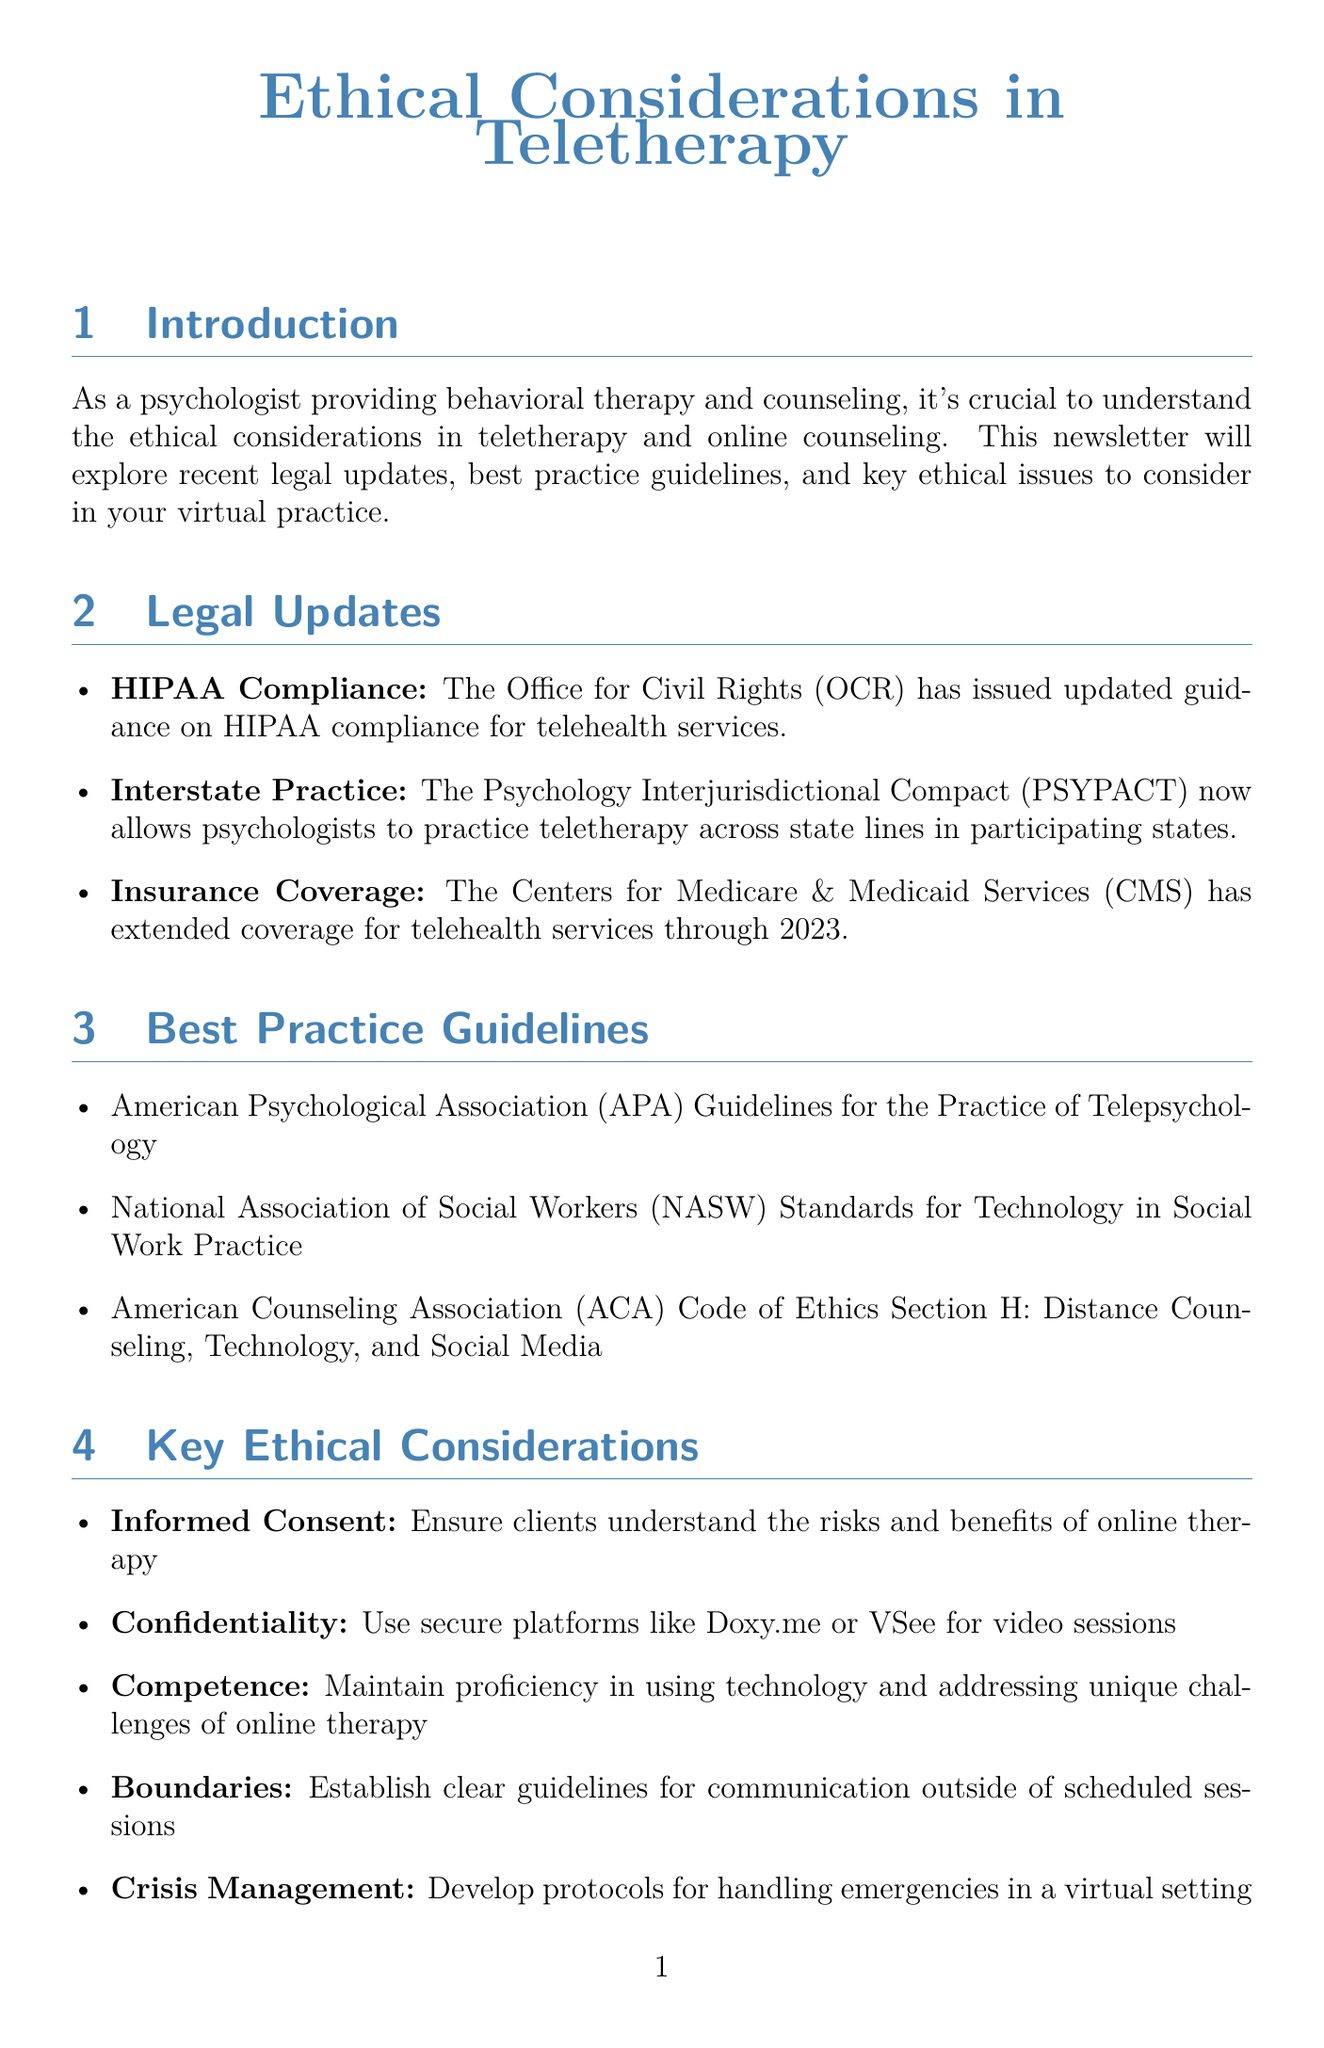What is the title of the newsletter? The title is explicitly stated at the beginning of the document, which is "Ethical Considerations in Teletherapy."
Answer: Ethical Considerations in Teletherapy Who issued updated guidance on HIPAA compliance? The Office for Civil Rights (OCR) is mentioned as the issuing authority for the updated guidance on HIPAA compliance.
Answer: Office for Civil Rights (OCR) What does PSYPACT allow psychologists to do? PSYPACT facilitates teletherapy across state lines for psychologists practicing in participating states.
Answer: Practice teletherapy across state lines Which organization provides guidelines for the practice of telepsychology? The American Psychological Association (APA) is referred to as the organization that provides these guidelines.
Answer: American Psychological Association (APA) What is a key ethical consideration related to client communication? The document specifies establishing guidelines for communication outside of scheduled sessions as a key ethical consideration.
Answer: Boundaries Which security measure is recommended in the newsletter? The document highlights two-factor authentication as a recommended security measure.
Answer: Two-factor authentication Name one credential offered for telehealth providers. The document lists the Board Certified-TeleMental Health Provider (BC-TMH) credential as an option.
Answer: Board Certified-TeleMental Health Provider (BC-TMH) What is an important aspect of cultural competence in online therapy? The importance of understanding how cultural factors may affect the therapeutic relationship in a virtual setting is emphasized.
Answer: Cultural factors What should a psychologist develop for emergencies in teletherapy? Developing protocols for handling emergencies is emphasized in the document as an important step for psychologists.
Answer: Protocols for handling emergencies 